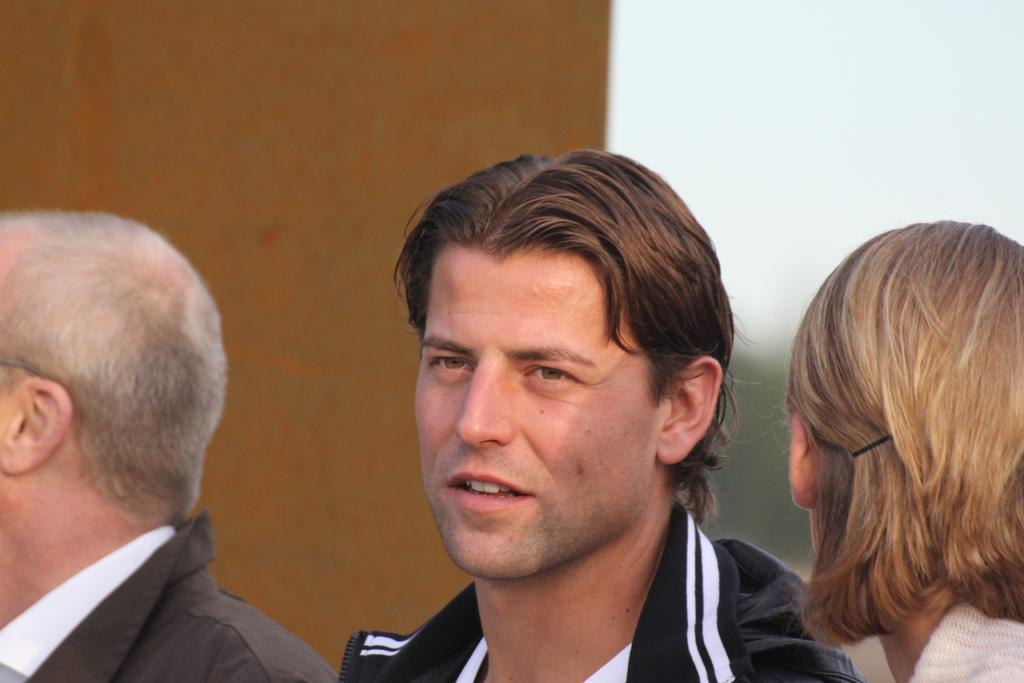What is located in the foreground of the image? There are people in the foreground of the image. What can be seen in the background of the image? There is a wall in the background of the image. What type of soap is being used by the people in the image? There is no soap present in the image; it only features people in the foreground and a wall in the background. 